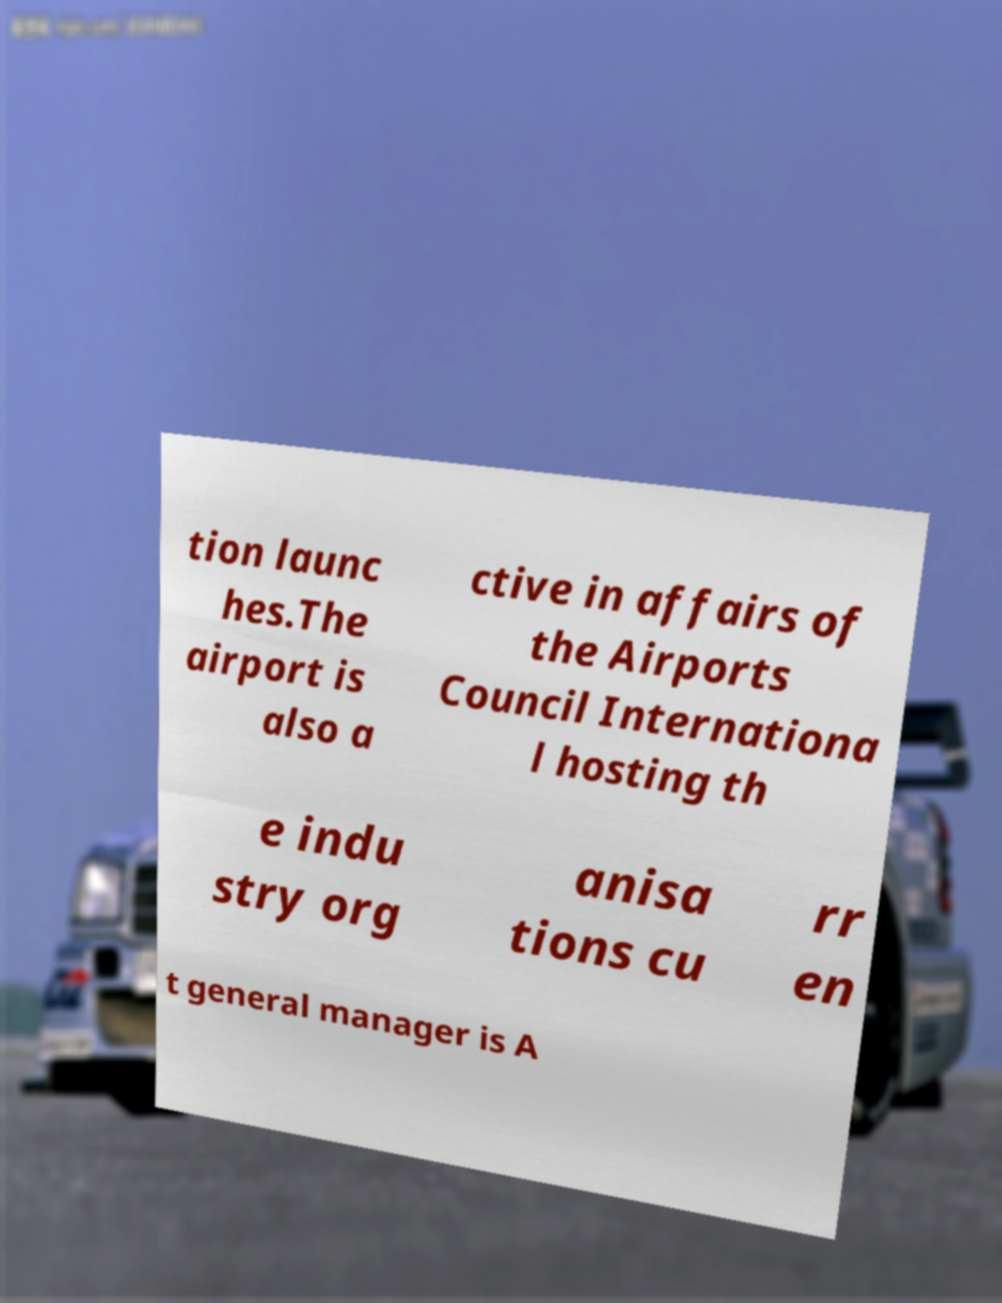Please identify and transcribe the text found in this image. tion launc hes.The airport is also a ctive in affairs of the Airports Council Internationa l hosting th e indu stry org anisa tions cu rr en t general manager is A 